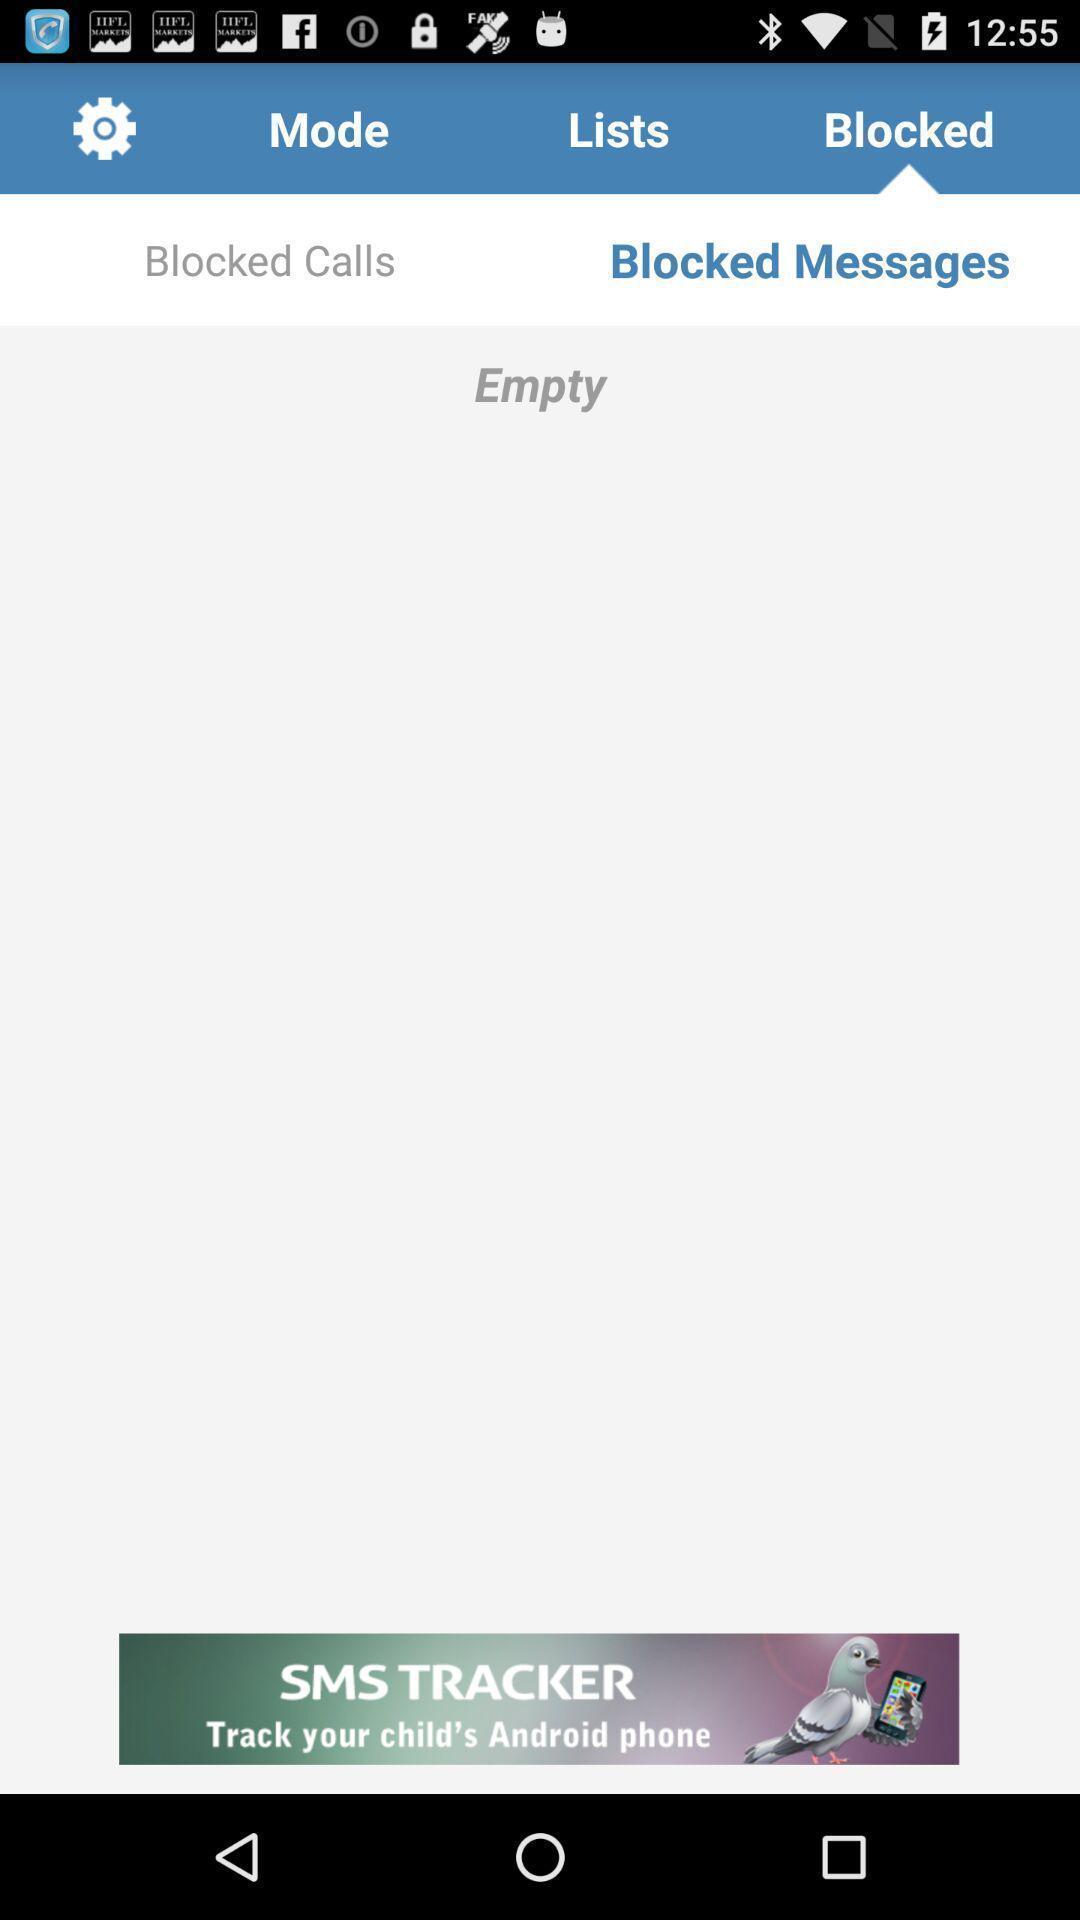Provide a detailed account of this screenshot. Screen showing empty in blocked messages. 